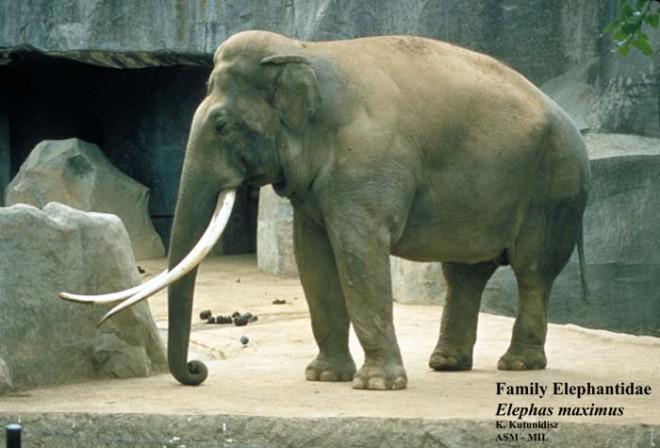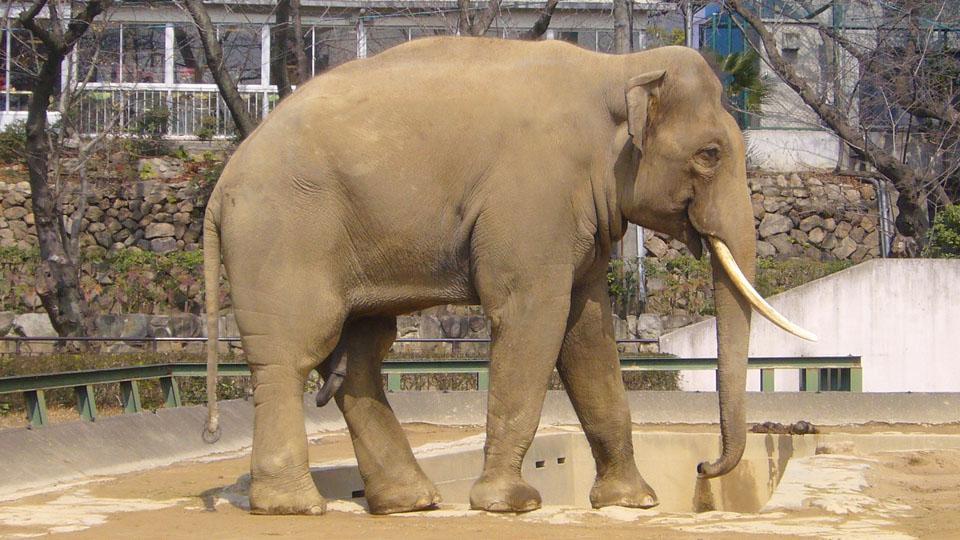The first image is the image on the left, the second image is the image on the right. Evaluate the accuracy of this statement regarding the images: "At least one elephant has it's trunk raised in one image.". Is it true? Answer yes or no. No. The first image is the image on the left, the second image is the image on the right. Analyze the images presented: Is the assertion "There is at least one elephant lifting its trunk in the air." valid? Answer yes or no. No. 